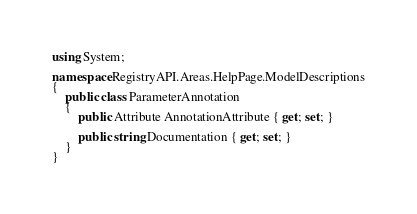<code> <loc_0><loc_0><loc_500><loc_500><_C#_>using System;

namespace RegistryAPI.Areas.HelpPage.ModelDescriptions
{
    public class ParameterAnnotation
    {
        public Attribute AnnotationAttribute { get; set; }

        public string Documentation { get; set; }
    }
}</code> 